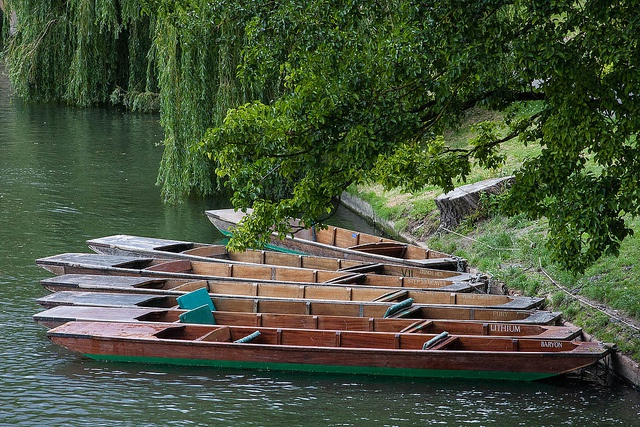Describe the objects in this image and their specific colors. I can see boat in gray, maroon, black, lavender, and brown tones, boat in gray, black, and darkgray tones, boat in gray, darkgray, and black tones, boat in gray, brown, black, and darkgray tones, and boat in gray, tan, darkgray, and black tones in this image. 